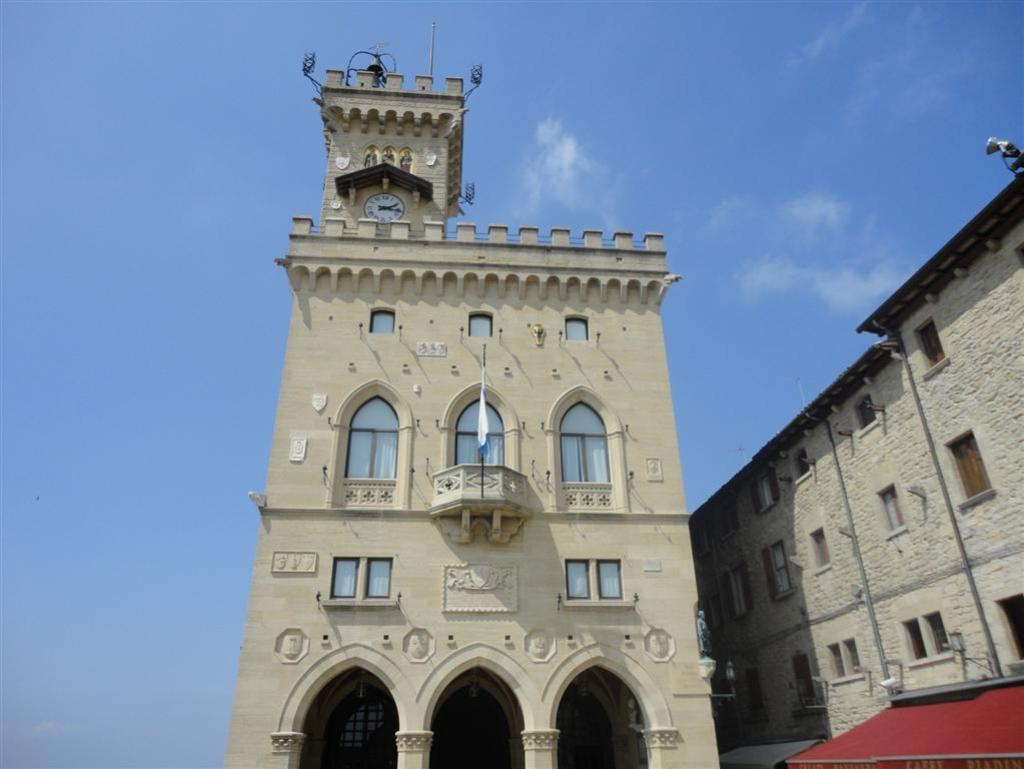What type of structure is located on the right corner of the image? There is a building with windows on the right corner of the image. Can you describe the building in the image? There is a building in the image. What feature is common to both buildings in the image? Both buildings have windows. What is the symbol visible in the image? There is a flag visible in the image. What time-telling device is present in the image? There is a clock in the image. What is visible at the top of the image? The sky is visible at the top of the image. Where is the shelf located in the image? There is no shelf present in the image. Can you tell me how many volleyballs are visible in the image? There are no volleyballs present in the image. 